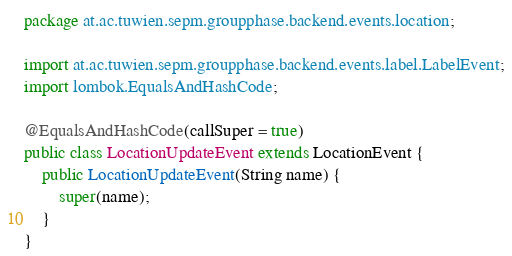<code> <loc_0><loc_0><loc_500><loc_500><_Java_>package at.ac.tuwien.sepm.groupphase.backend.events.location;

import at.ac.tuwien.sepm.groupphase.backend.events.label.LabelEvent;
import lombok.EqualsAndHashCode;

@EqualsAndHashCode(callSuper = true)
public class LocationUpdateEvent extends LocationEvent {
    public LocationUpdateEvent(String name) {
        super(name);
    }
}
</code> 